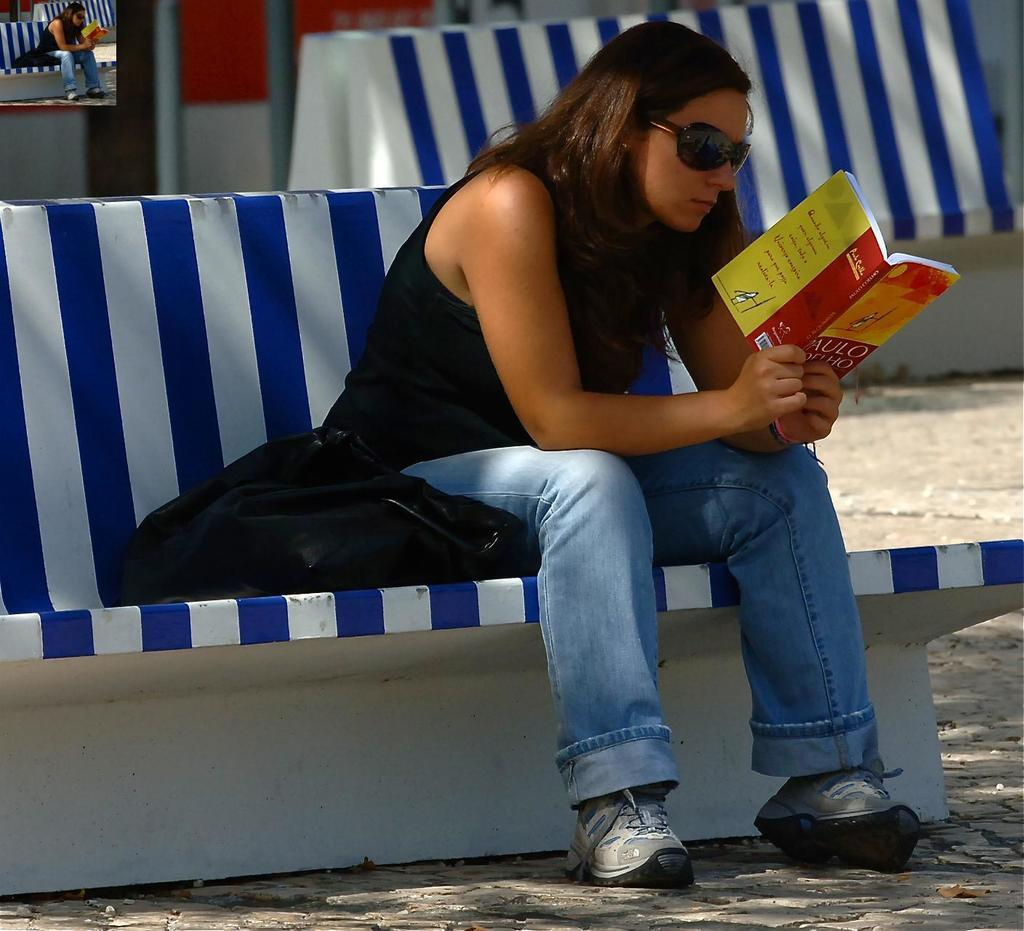<image>
Render a clear and concise summary of the photo. the word Aulo is on the front of a book 